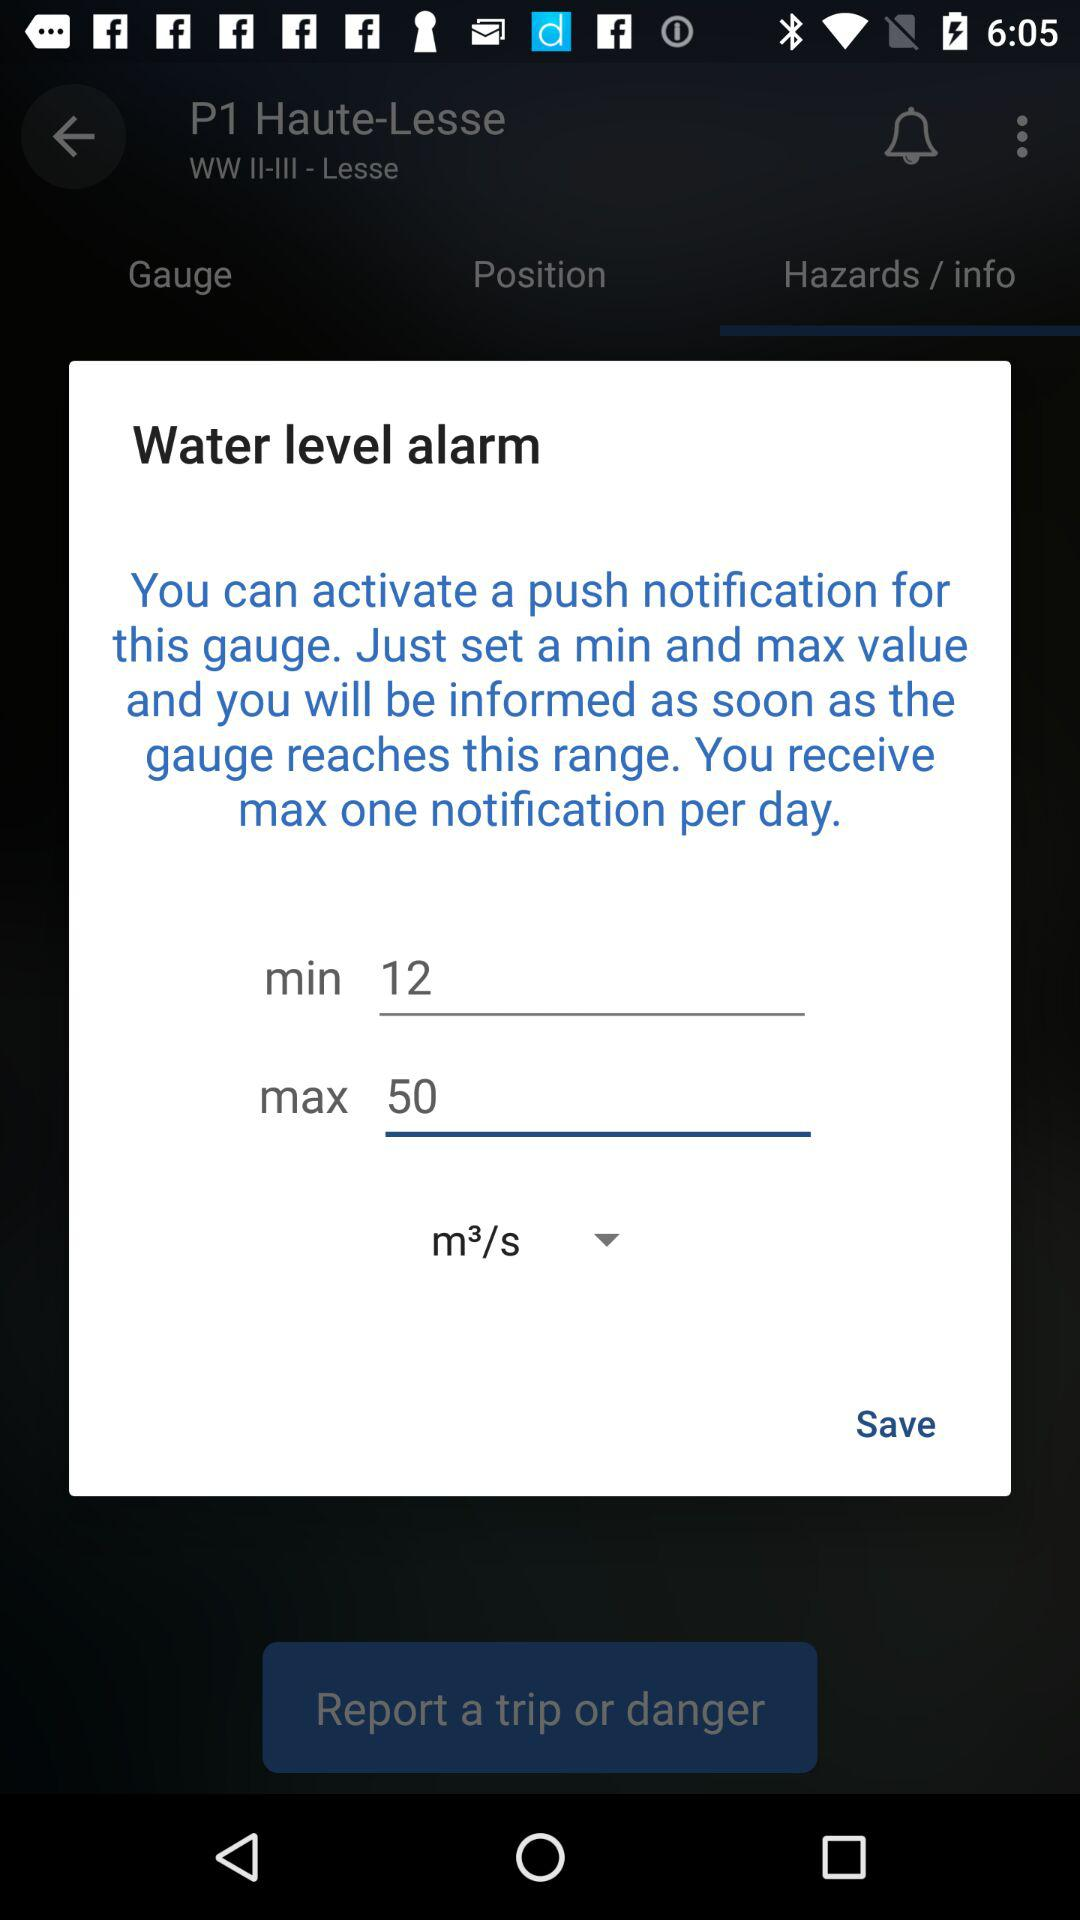What is the difference between the max and min values?
Answer the question using a single word or phrase. 38 